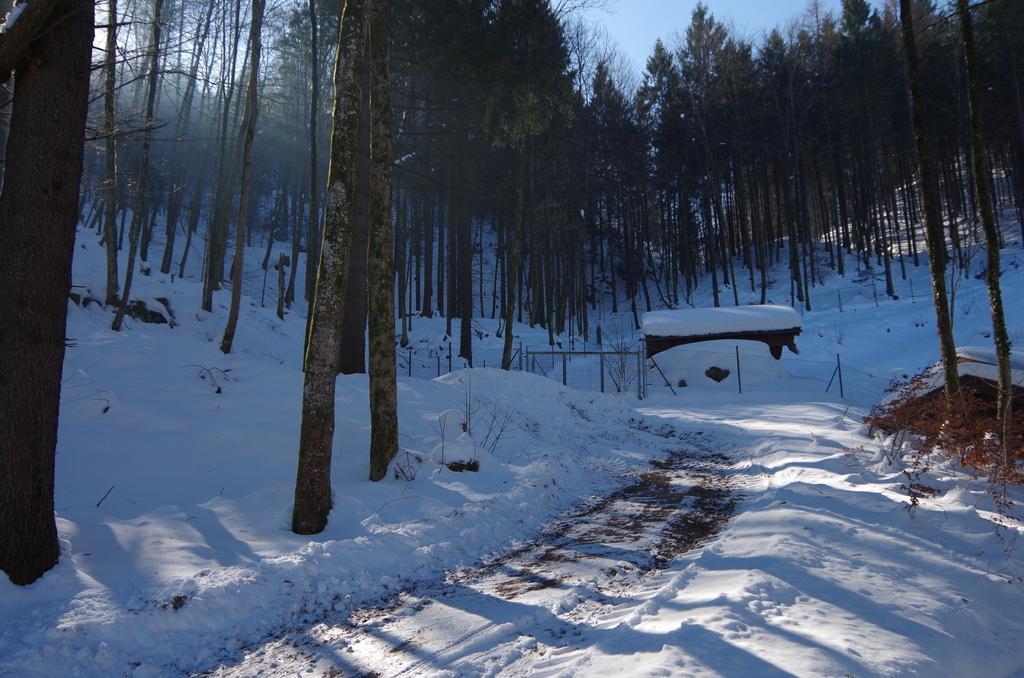How would you summarize this image in a sentence or two? In the image there is a snow surface and in between that surface there are tall trees. 